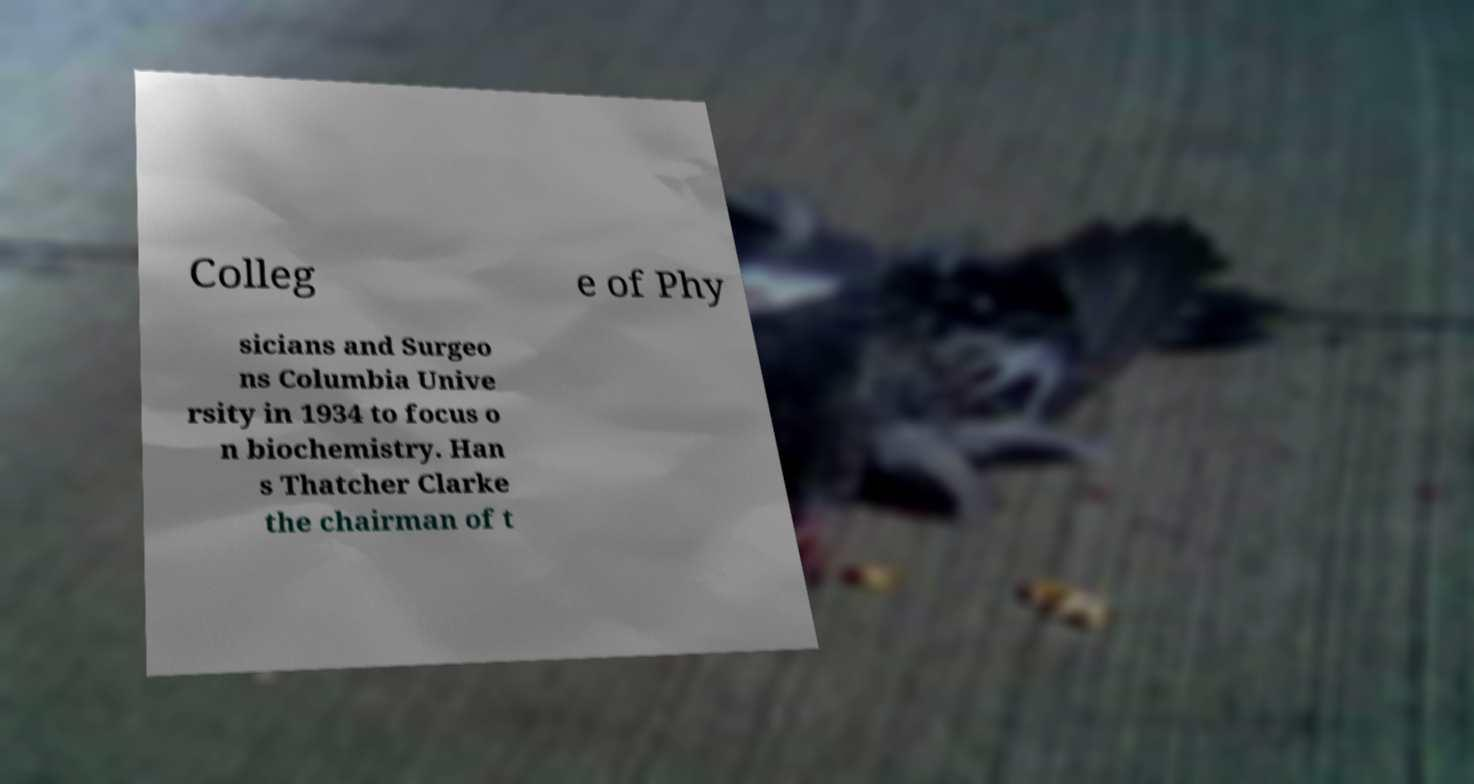Please read and relay the text visible in this image. What does it say? Colleg e of Phy sicians and Surgeo ns Columbia Unive rsity in 1934 to focus o n biochemistry. Han s Thatcher Clarke the chairman of t 